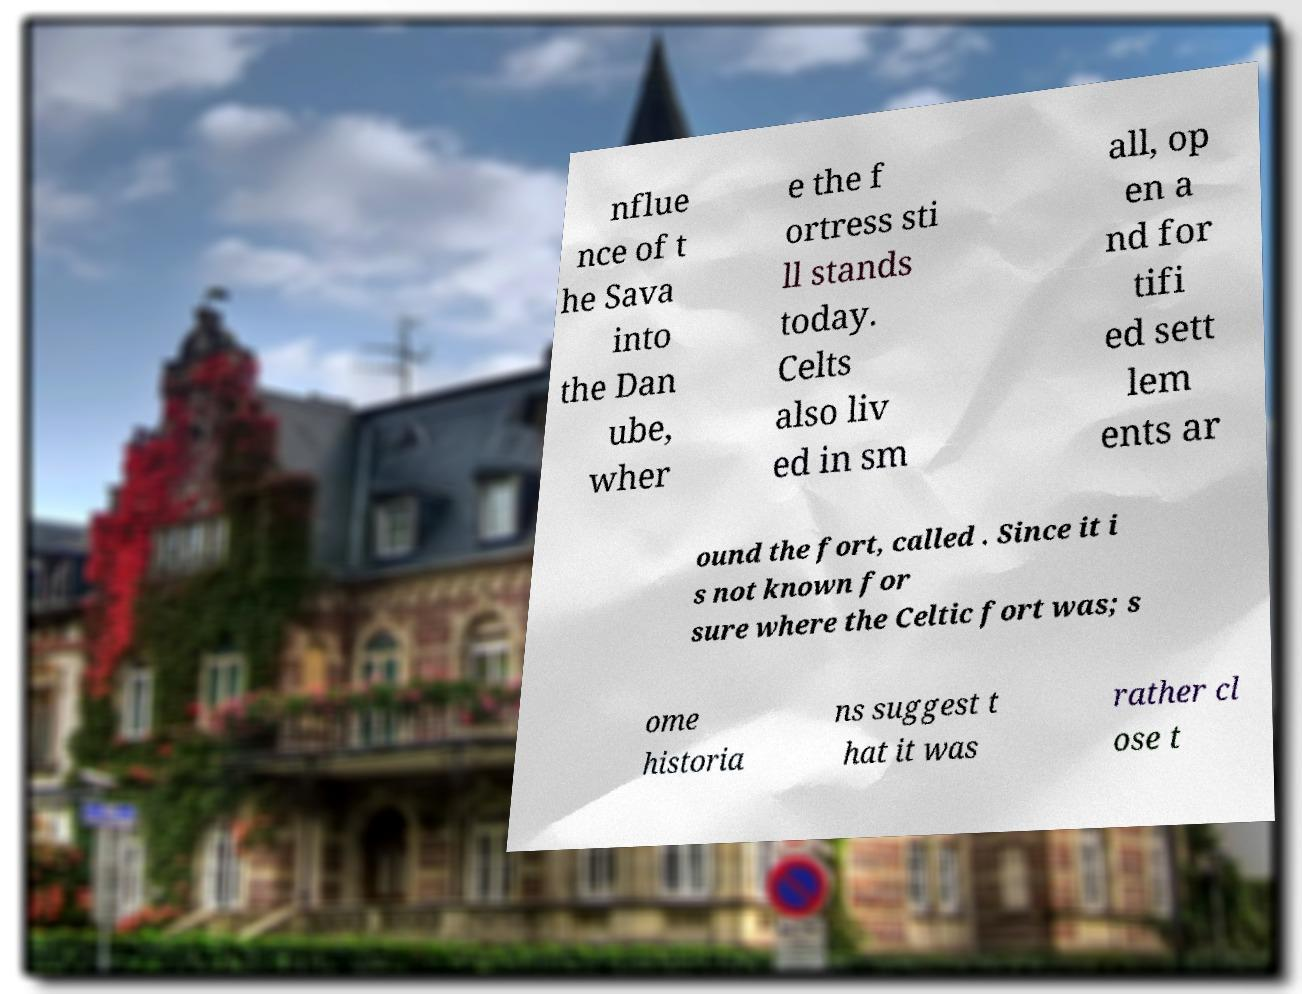There's text embedded in this image that I need extracted. Can you transcribe it verbatim? nflue nce of t he Sava into the Dan ube, wher e the f ortress sti ll stands today. Celts also liv ed in sm all, op en a nd for tifi ed sett lem ents ar ound the fort, called . Since it i s not known for sure where the Celtic fort was; s ome historia ns suggest t hat it was rather cl ose t 